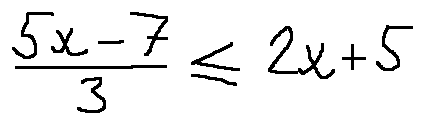Convert formula to latex. <formula><loc_0><loc_0><loc_500><loc_500>\frac { 5 x - 7 } { 3 } \leq 2 x + 5</formula> 